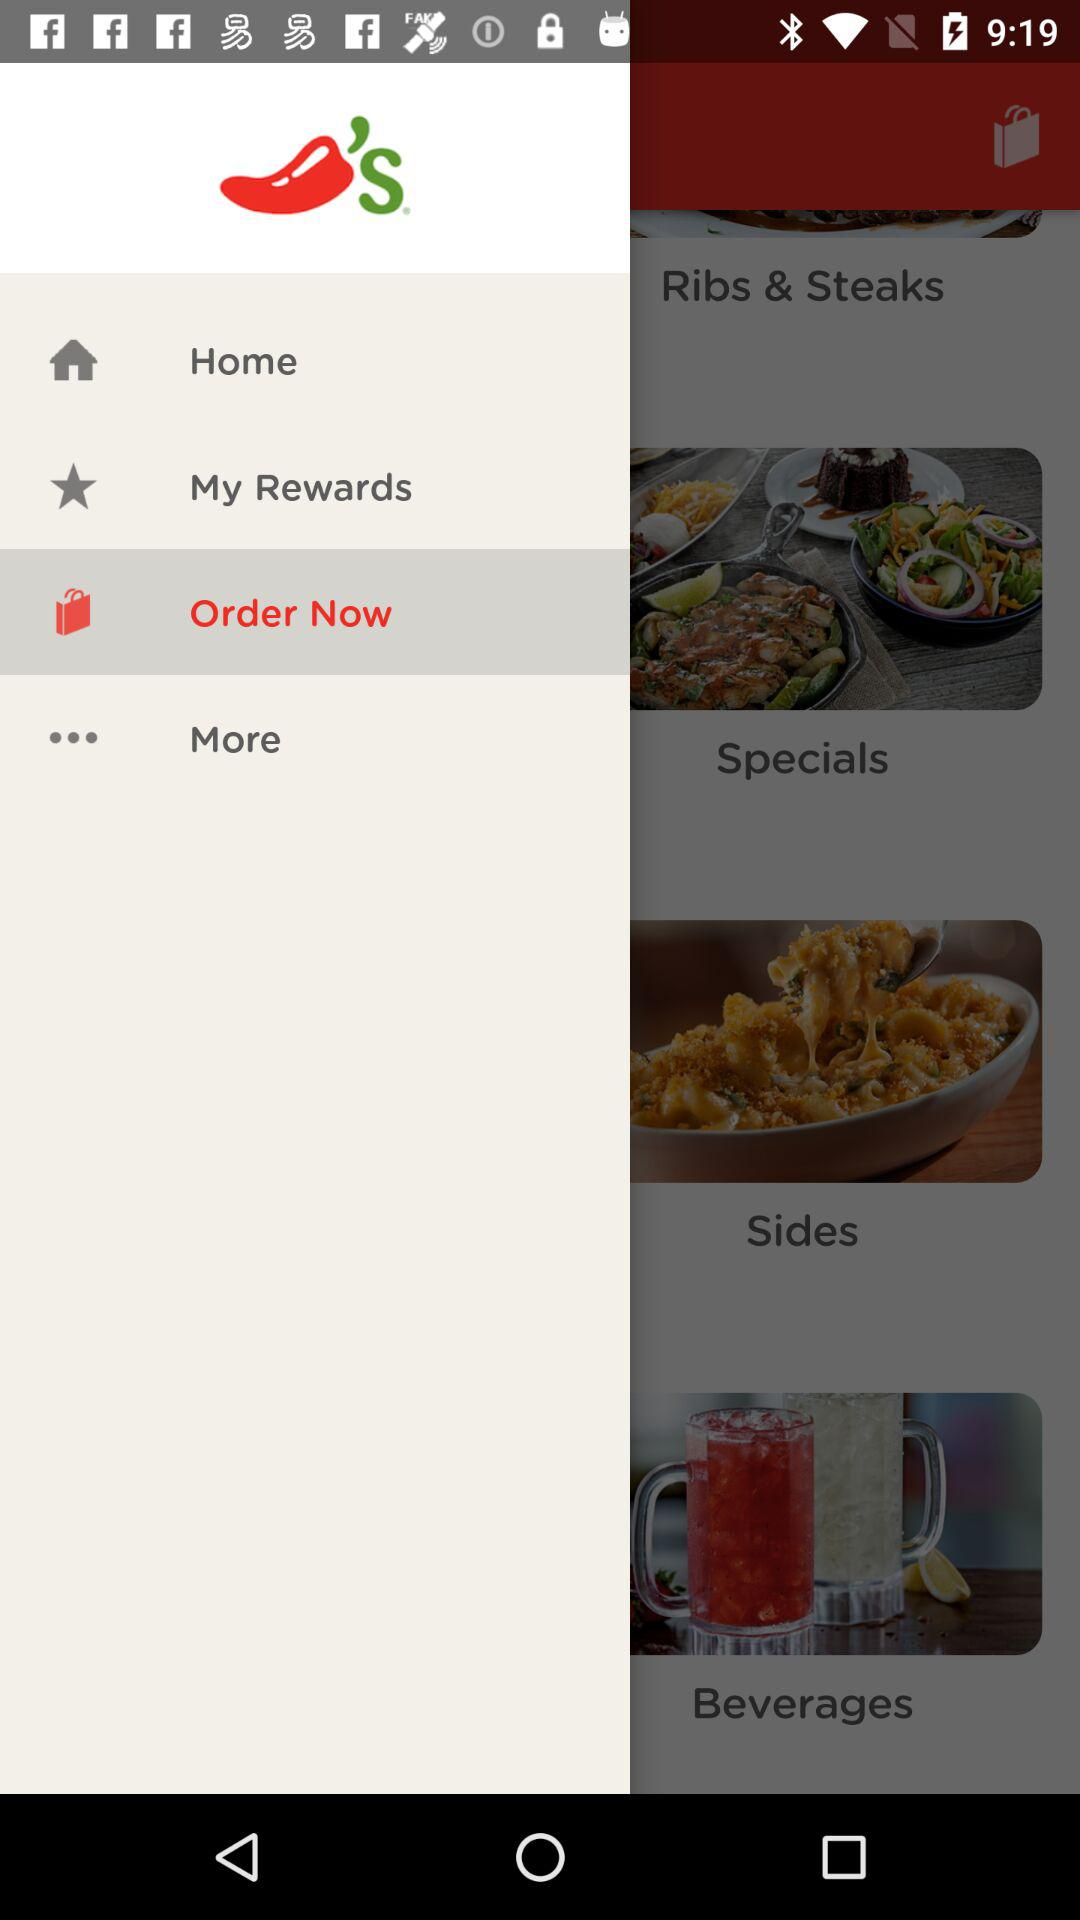Which item is selected in the menu? The selected item is "Order Now". 